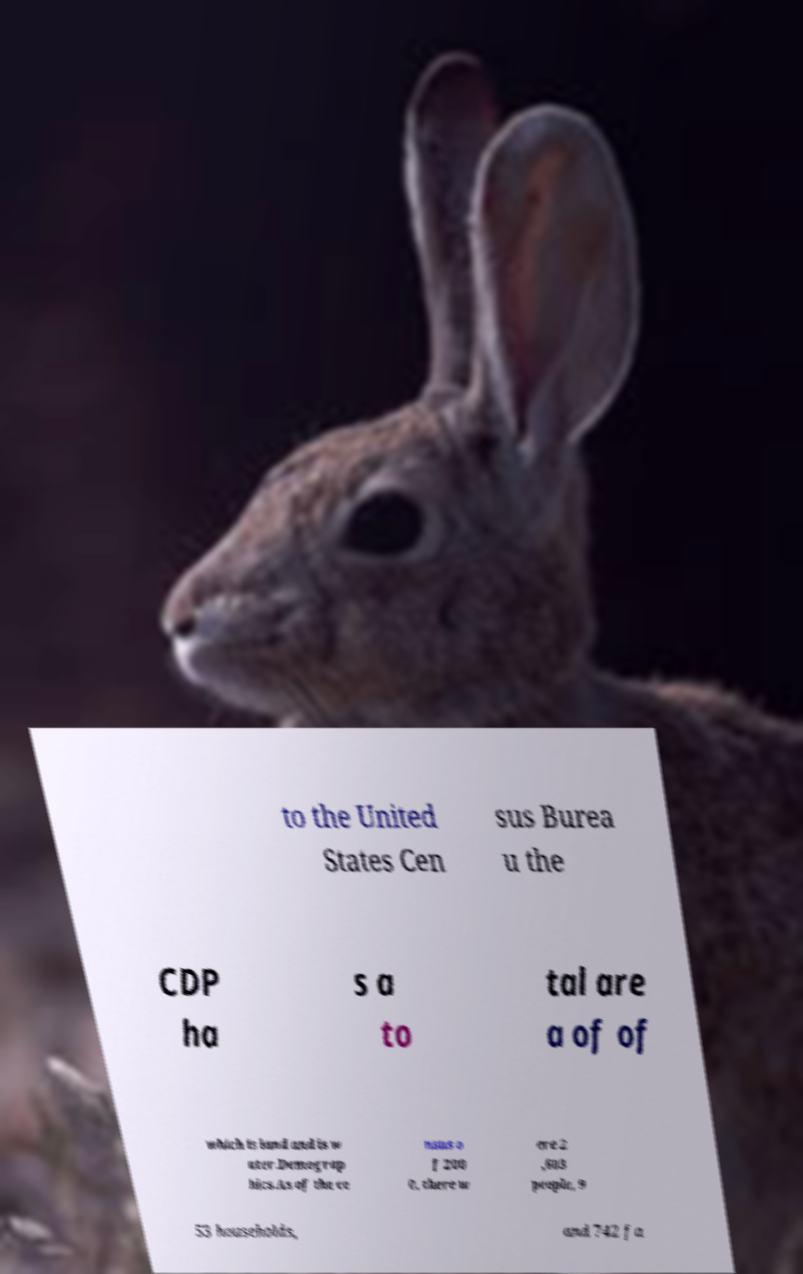Please read and relay the text visible in this image. What does it say? to the United States Cen sus Burea u the CDP ha s a to tal are a of of which is land and is w ater.Demograp hics.As of the ce nsus o f 200 0, there w ere 2 ,603 people, 9 53 households, and 742 fa 